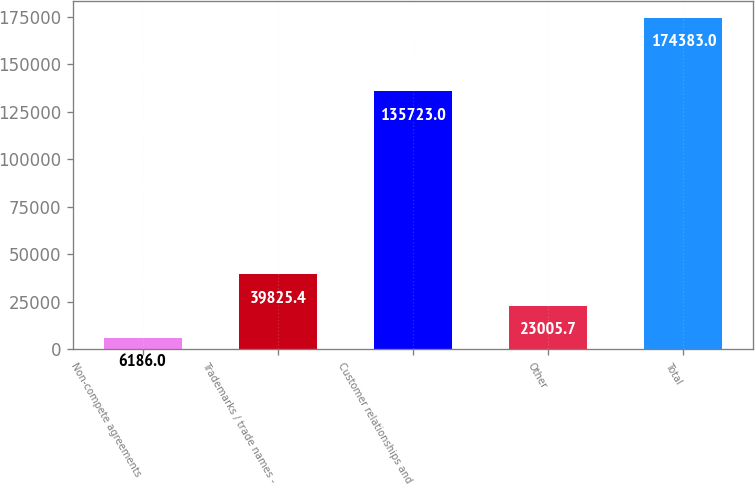Convert chart to OTSL. <chart><loc_0><loc_0><loc_500><loc_500><bar_chart><fcel>Non-compete agreements<fcel>Trademarks / trade names -<fcel>Customer relationships and<fcel>Other<fcel>Total<nl><fcel>6186<fcel>39825.4<fcel>135723<fcel>23005.7<fcel>174383<nl></chart> 